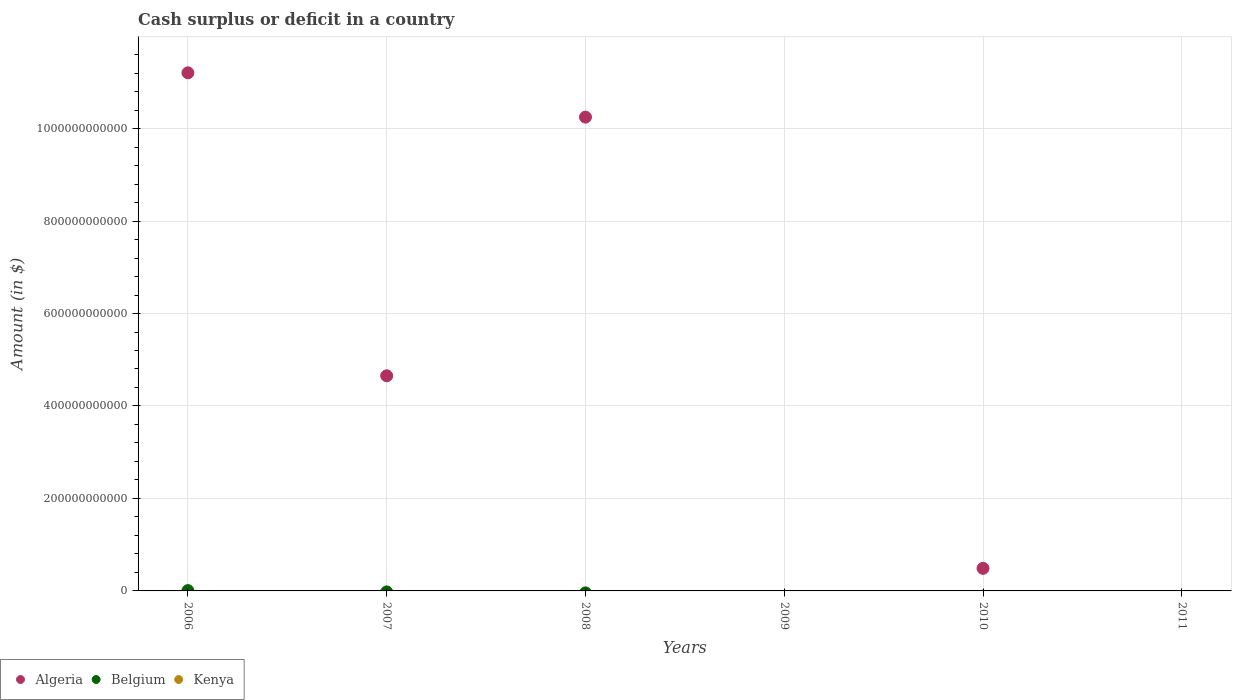How many different coloured dotlines are there?
Ensure brevity in your answer.  2. Across all years, what is the maximum amount of cash surplus or deficit in Algeria?
Your answer should be compact. 1.12e+12. In which year was the amount of cash surplus or deficit in Belgium maximum?
Your response must be concise. 2006. What is the total amount of cash surplus or deficit in Algeria in the graph?
Keep it short and to the point. 2.66e+12. What is the difference between the amount of cash surplus or deficit in Algeria in 2007 and that in 2010?
Give a very brief answer. 4.16e+11. What is the difference between the amount of cash surplus or deficit in Belgium in 2007 and the amount of cash surplus or deficit in Algeria in 2010?
Ensure brevity in your answer.  -4.88e+1. What is the average amount of cash surplus or deficit in Belgium per year?
Offer a terse response. 1.05e+08. In the year 2006, what is the difference between the amount of cash surplus or deficit in Algeria and amount of cash surplus or deficit in Belgium?
Make the answer very short. 1.12e+12. What is the difference between the highest and the second highest amount of cash surplus or deficit in Algeria?
Provide a short and direct response. 9.58e+1. What is the difference between the highest and the lowest amount of cash surplus or deficit in Algeria?
Offer a very short reply. 1.12e+12. Is it the case that in every year, the sum of the amount of cash surplus or deficit in Belgium and amount of cash surplus or deficit in Algeria  is greater than the amount of cash surplus or deficit in Kenya?
Provide a short and direct response. No. Is the amount of cash surplus or deficit in Belgium strictly greater than the amount of cash surplus or deficit in Kenya over the years?
Offer a very short reply. Yes. Is the amount of cash surplus or deficit in Algeria strictly less than the amount of cash surplus or deficit in Kenya over the years?
Make the answer very short. No. What is the difference between two consecutive major ticks on the Y-axis?
Make the answer very short. 2.00e+11. Does the graph contain any zero values?
Make the answer very short. Yes. Where does the legend appear in the graph?
Make the answer very short. Bottom left. What is the title of the graph?
Your response must be concise. Cash surplus or deficit in a country. Does "Korea (Democratic)" appear as one of the legend labels in the graph?
Provide a succinct answer. No. What is the label or title of the X-axis?
Offer a terse response. Years. What is the label or title of the Y-axis?
Your answer should be very brief. Amount (in $). What is the Amount (in $) of Algeria in 2006?
Offer a terse response. 1.12e+12. What is the Amount (in $) of Belgium in 2006?
Keep it short and to the point. 6.27e+08. What is the Amount (in $) of Algeria in 2007?
Your answer should be very brief. 4.65e+11. What is the Amount (in $) in Algeria in 2008?
Your answer should be compact. 1.02e+12. What is the Amount (in $) in Kenya in 2008?
Your response must be concise. 0. What is the Amount (in $) of Belgium in 2009?
Give a very brief answer. 0. What is the Amount (in $) in Algeria in 2010?
Offer a very short reply. 4.88e+1. What is the Amount (in $) of Belgium in 2010?
Make the answer very short. 0. What is the Amount (in $) in Belgium in 2011?
Make the answer very short. 0. Across all years, what is the maximum Amount (in $) in Algeria?
Make the answer very short. 1.12e+12. Across all years, what is the maximum Amount (in $) in Belgium?
Offer a terse response. 6.27e+08. Across all years, what is the minimum Amount (in $) in Belgium?
Your answer should be very brief. 0. What is the total Amount (in $) in Algeria in the graph?
Give a very brief answer. 2.66e+12. What is the total Amount (in $) in Belgium in the graph?
Ensure brevity in your answer.  6.27e+08. What is the total Amount (in $) in Kenya in the graph?
Keep it short and to the point. 0. What is the difference between the Amount (in $) in Algeria in 2006 and that in 2007?
Provide a short and direct response. 6.55e+11. What is the difference between the Amount (in $) of Algeria in 2006 and that in 2008?
Offer a terse response. 9.58e+1. What is the difference between the Amount (in $) in Algeria in 2006 and that in 2010?
Your answer should be very brief. 1.07e+12. What is the difference between the Amount (in $) of Algeria in 2007 and that in 2008?
Provide a short and direct response. -5.59e+11. What is the difference between the Amount (in $) of Algeria in 2007 and that in 2010?
Your answer should be very brief. 4.16e+11. What is the difference between the Amount (in $) in Algeria in 2008 and that in 2010?
Provide a short and direct response. 9.76e+11. What is the average Amount (in $) of Algeria per year?
Your answer should be compact. 4.43e+11. What is the average Amount (in $) in Belgium per year?
Your answer should be compact. 1.05e+08. In the year 2006, what is the difference between the Amount (in $) in Algeria and Amount (in $) in Belgium?
Ensure brevity in your answer.  1.12e+12. What is the ratio of the Amount (in $) in Algeria in 2006 to that in 2007?
Give a very brief answer. 2.41. What is the ratio of the Amount (in $) of Algeria in 2006 to that in 2008?
Your answer should be very brief. 1.09. What is the ratio of the Amount (in $) in Algeria in 2006 to that in 2010?
Ensure brevity in your answer.  22.95. What is the ratio of the Amount (in $) of Algeria in 2007 to that in 2008?
Make the answer very short. 0.45. What is the ratio of the Amount (in $) of Algeria in 2007 to that in 2010?
Your response must be concise. 9.53. What is the ratio of the Amount (in $) in Algeria in 2008 to that in 2010?
Provide a succinct answer. 20.99. What is the difference between the highest and the second highest Amount (in $) of Algeria?
Provide a succinct answer. 9.58e+1. What is the difference between the highest and the lowest Amount (in $) of Algeria?
Provide a succinct answer. 1.12e+12. What is the difference between the highest and the lowest Amount (in $) in Belgium?
Your answer should be very brief. 6.27e+08. 